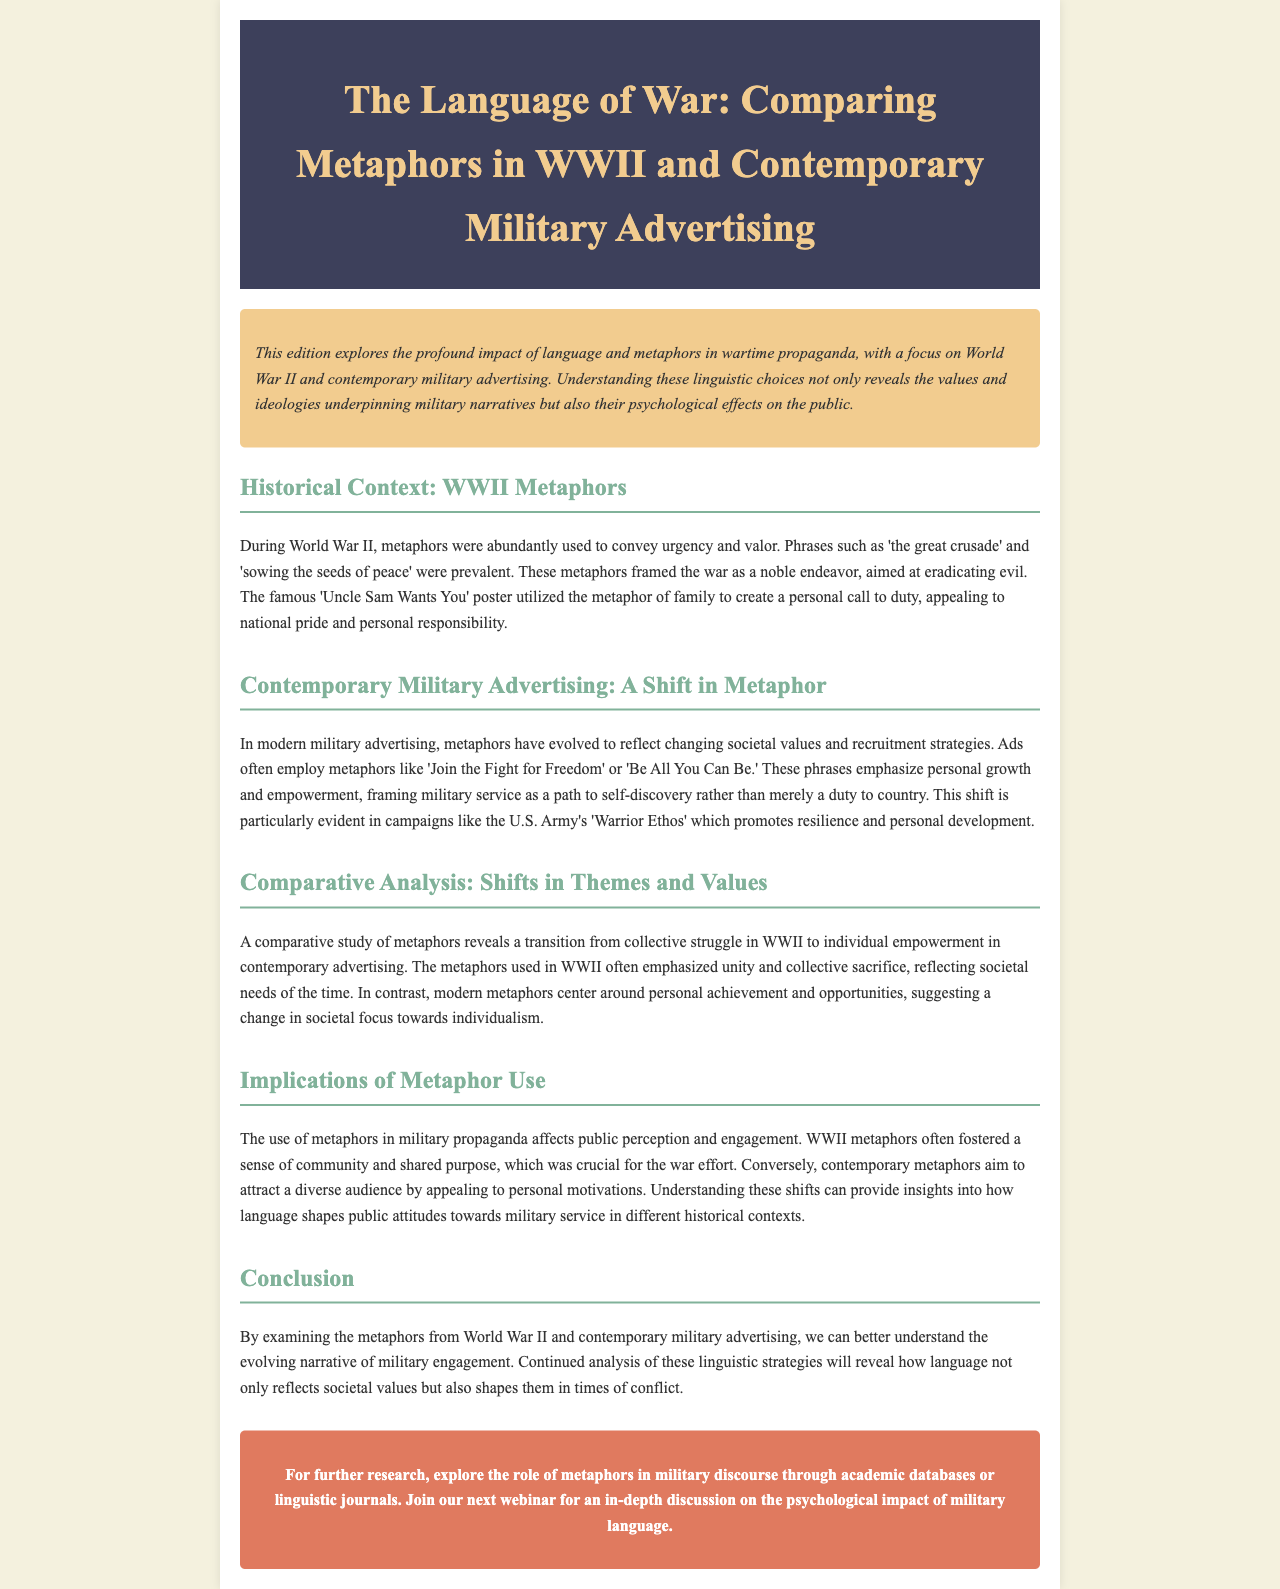What was the title of the newsletter? The title of the newsletter is the first heading in the document.
Answer: The Language of War: Comparing Metaphors in WWII and Contemporary Military Advertising What metaphor was used in WWII to convey urgency and valor? The document provides examples of metaphors used during WWII, highlighting one specific phrase related to urgency and valor.
Answer: the great crusade What is a contemporary metaphor used in military advertising? The document mentions specific phrases used in contemporary military advertising to illustrate current metaphor usage.
Answer: Join the Fight for Freedom What shift in focus is noted between WWII metaphors and contemporary metaphors? The document discusses the thematic transition from collective to individual perspectives in metaphor usage.
Answer: individual empowerment Which campaign is cited as promoting resilience and personal development? The document references a specific modern campaign that emphasizes personal growth.
Answer: U.S. Army's Warrior Ethos What psychological effect did WWII metaphors have on the public? The document explains the impact of WWII metaphors on public engagement and perception as part of the analysis.
Answer: sense of community What is the primary theme of the conclusion in the document? The conclusion summarizes the overall takeaway regarding the study of metaphors throughout military engagement.
Answer: evolving narrative of military engagement In what section of the document is the metaphor 'sowing the seeds of peace' mentioned? The document organizes its content into sections, and this metaphor is specifically discussed in the section about WWII metaphors.
Answer: Historical Context: WWII Metaphors 